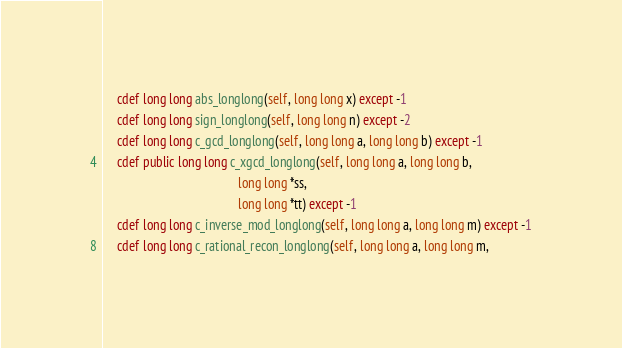<code> <loc_0><loc_0><loc_500><loc_500><_Cython_>    cdef long long abs_longlong(self, long long x) except -1
    cdef long long sign_longlong(self, long long n) except -2
    cdef long long c_gcd_longlong(self, long long a, long long b) except -1
    cdef public long long c_xgcd_longlong(self, long long a, long long b,
                                          long long *ss,
                                          long long *tt) except -1
    cdef long long c_inverse_mod_longlong(self, long long a, long long m) except -1
    cdef long long c_rational_recon_longlong(self, long long a, long long m,</code> 